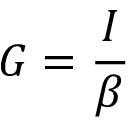Convert formula to latex. <formula><loc_0><loc_0><loc_500><loc_500>G = \frac { I } { \beta }</formula> 